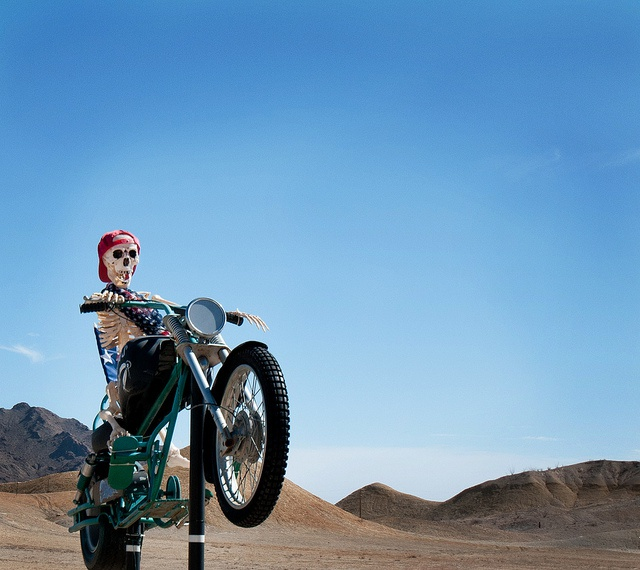Describe the objects in this image and their specific colors. I can see a motorcycle in gray, black, blue, and lightblue tones in this image. 